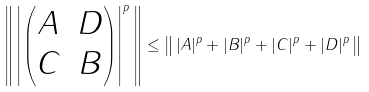<formula> <loc_0><loc_0><loc_500><loc_500>\left \| \, \left | \begin{pmatrix} A & D \\ C & B \end{pmatrix} \right | ^ { p } \, \right \| \leq \left \| \, | A | ^ { p } + | B | ^ { p } + | C | ^ { p } + | D | ^ { p } \, \right \|</formula> 